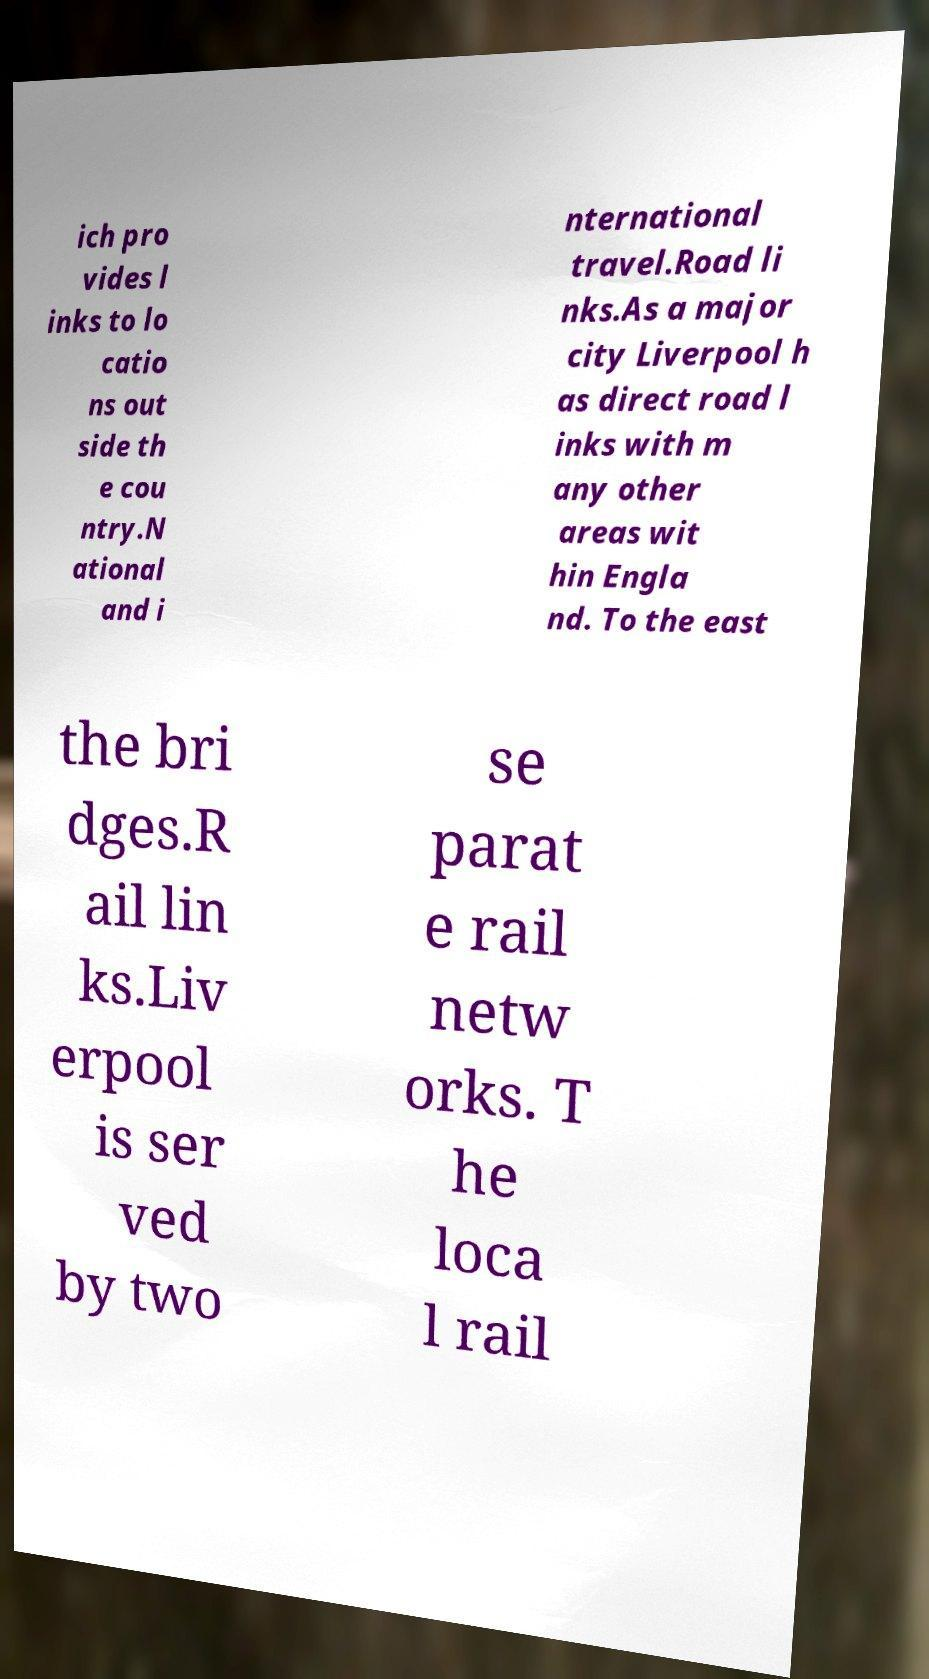Please read and relay the text visible in this image. What does it say? ich pro vides l inks to lo catio ns out side th e cou ntry.N ational and i nternational travel.Road li nks.As a major city Liverpool h as direct road l inks with m any other areas wit hin Engla nd. To the east the bri dges.R ail lin ks.Liv erpool is ser ved by two se parat e rail netw orks. T he loca l rail 